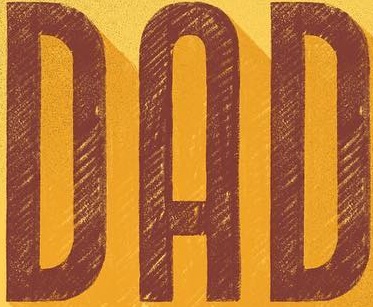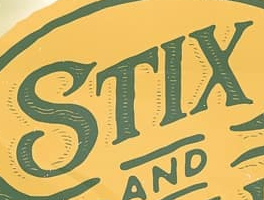What words can you see in these images in sequence, separated by a semicolon? DAD; STIX 